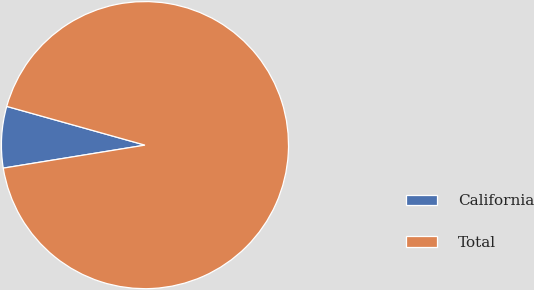Convert chart. <chart><loc_0><loc_0><loc_500><loc_500><pie_chart><fcel>California<fcel>Total<nl><fcel>6.91%<fcel>93.09%<nl></chart> 